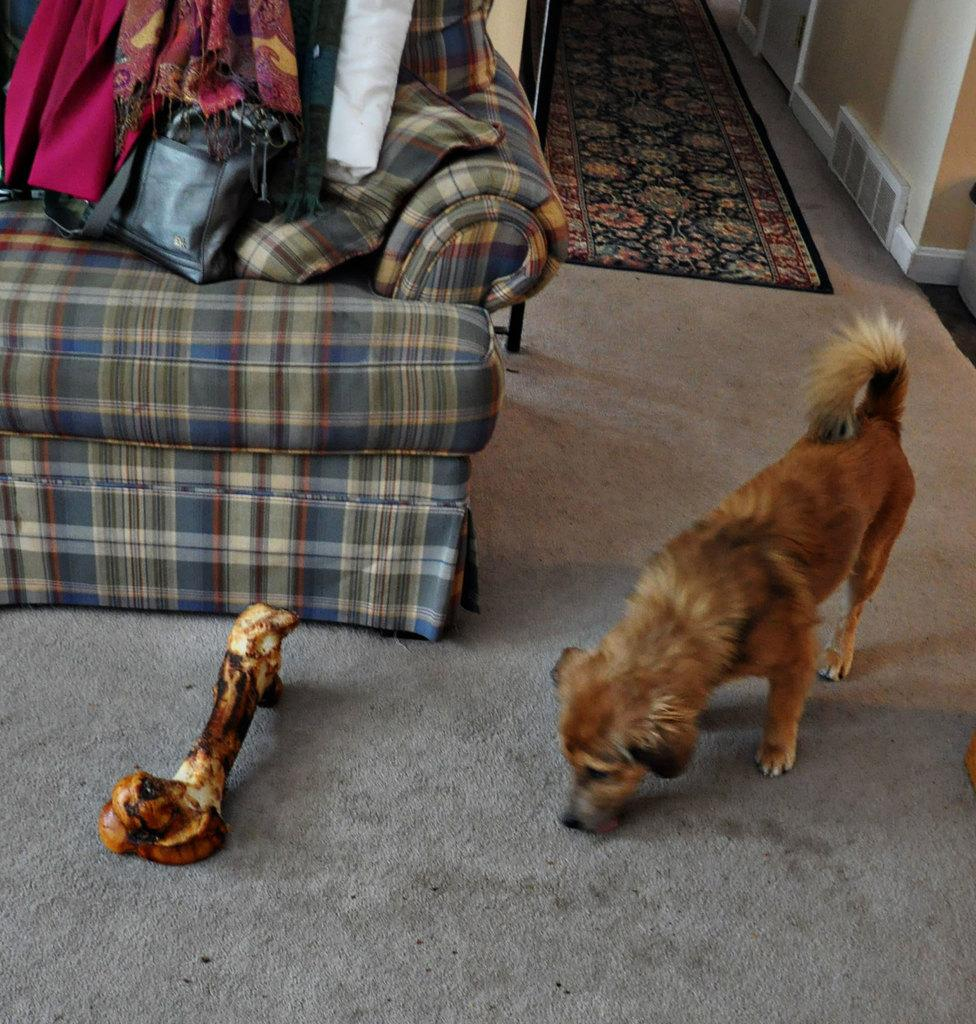What animal can be seen in the image? There is a dog in the image. What is the dog doing in the image? The dog is near a bone on the floor. What can be seen in the background of the image? There is a bed, a rug, clothes, a floor mat, and a wall in the background of the image. What type of room might the image have been taken in? The image may have been taken in a hall. What type of watch is the dog wearing in the image? There is no watch visible on the dog in the image. How many balloons are tied to the dog's collar in the image? There are no balloons present in the image. 